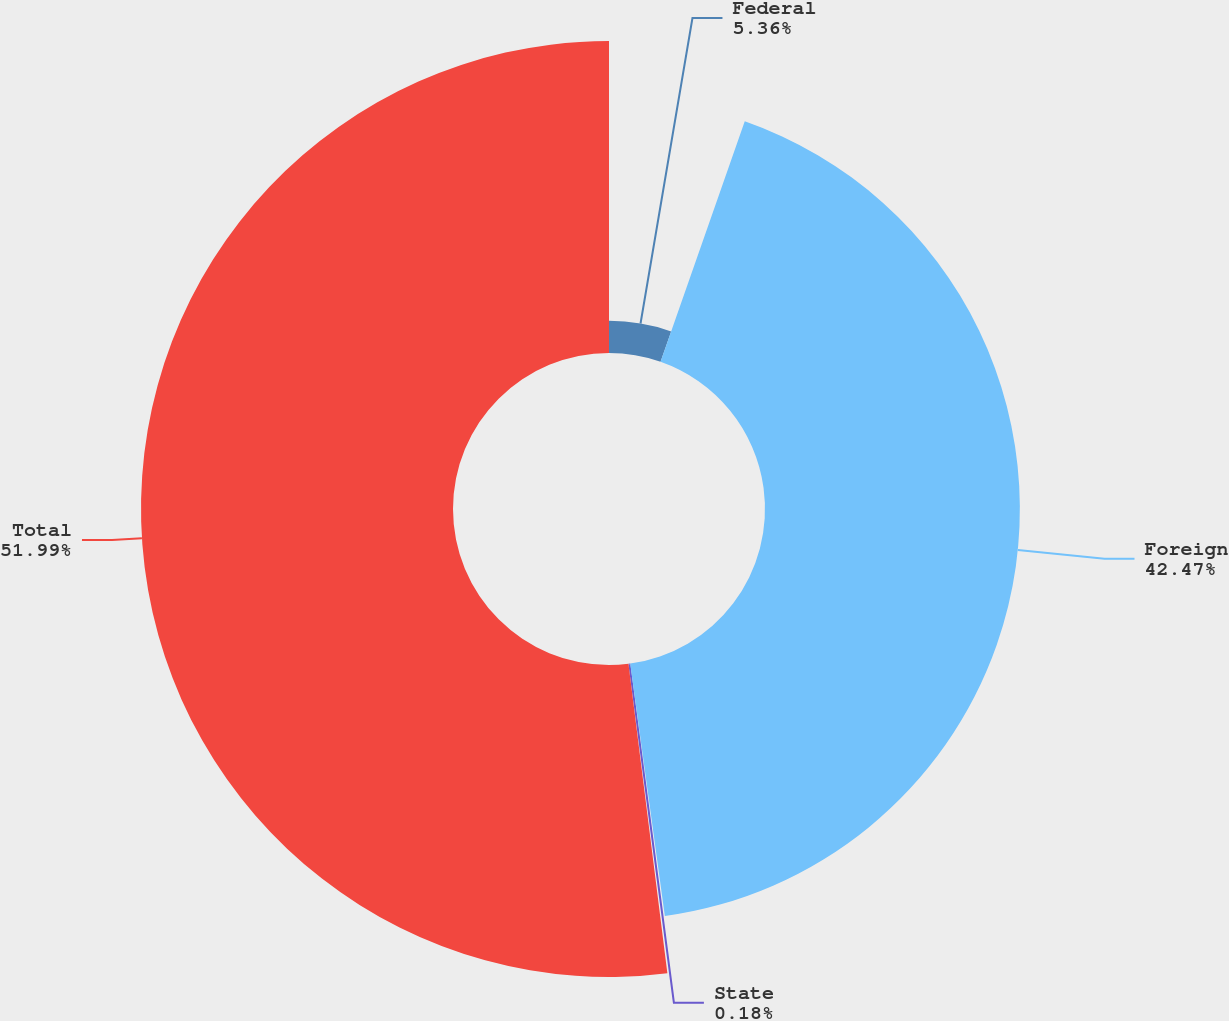Convert chart. <chart><loc_0><loc_0><loc_500><loc_500><pie_chart><fcel>Federal<fcel>Foreign<fcel>State<fcel>Total<nl><fcel>5.36%<fcel>42.47%<fcel>0.18%<fcel>51.99%<nl></chart> 